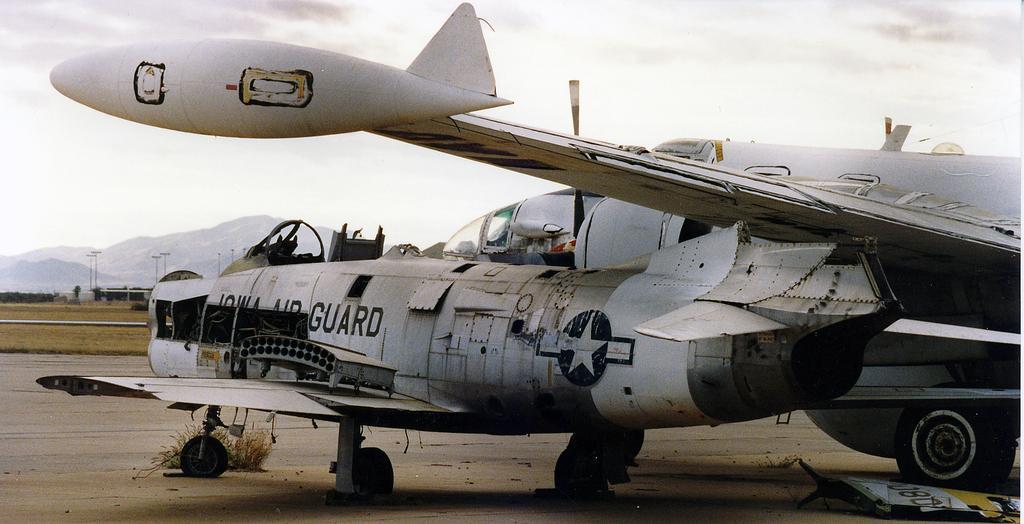Could you give a brief overview of what you see in this image? This image consists of planes in white color. At the bottom, there is a road. In the background, we can see a mountains and poles. At the top, there are clouds in the sky. 